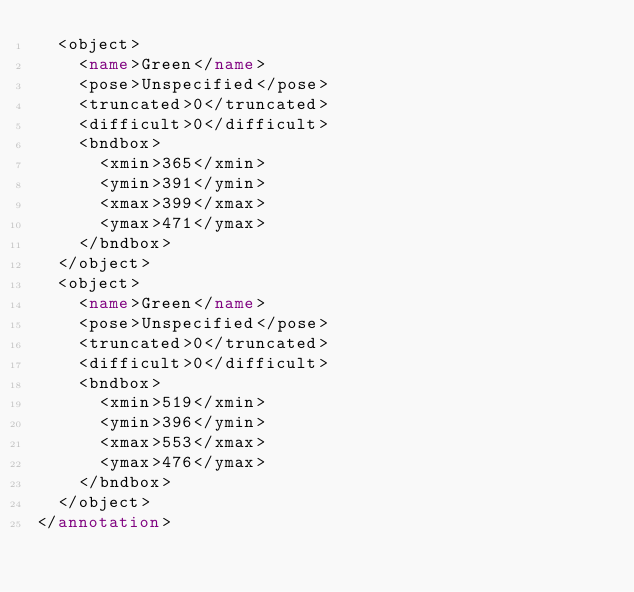<code> <loc_0><loc_0><loc_500><loc_500><_XML_>	<object>
		<name>Green</name>
		<pose>Unspecified</pose>
		<truncated>0</truncated>
		<difficult>0</difficult>
		<bndbox>
			<xmin>365</xmin>
			<ymin>391</ymin>
			<xmax>399</xmax>
			<ymax>471</ymax>
		</bndbox>
	</object>
	<object>
		<name>Green</name>
		<pose>Unspecified</pose>
		<truncated>0</truncated>
		<difficult>0</difficult>
		<bndbox>
			<xmin>519</xmin>
			<ymin>396</ymin>
			<xmax>553</xmax>
			<ymax>476</ymax>
		</bndbox>
	</object>
</annotation>
</code> 